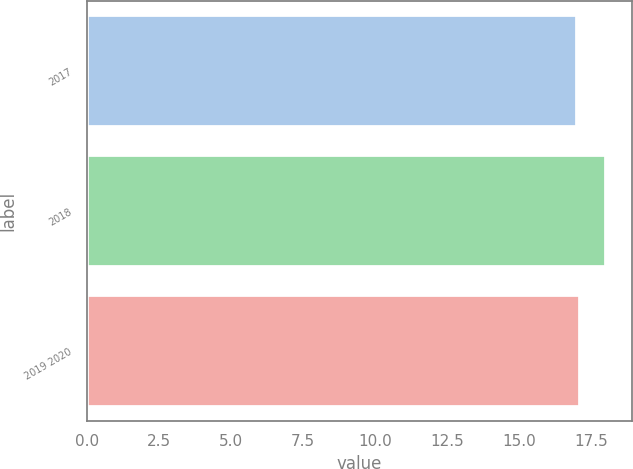Convert chart. <chart><loc_0><loc_0><loc_500><loc_500><bar_chart><fcel>2017<fcel>2018<fcel>2019 2020<nl><fcel>17<fcel>18<fcel>17.1<nl></chart> 